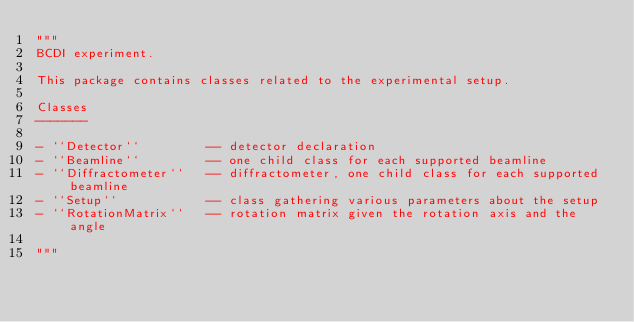Convert code to text. <code><loc_0><loc_0><loc_500><loc_500><_Python_>"""
BCDI experiment.

This package contains classes related to the experimental setup.

Classes
-------

- ``Detector``         -- detector declaration
- ``Beamline``         -- one child class for each supported beamline
- ``Diffractometer``   -- diffractometer, one child class for each supported beamline
- ``Setup``            -- class gathering various parameters about the setup
- ``RotationMatrix``   -- rotation matrix given the rotation axis and the angle

"""
</code> 